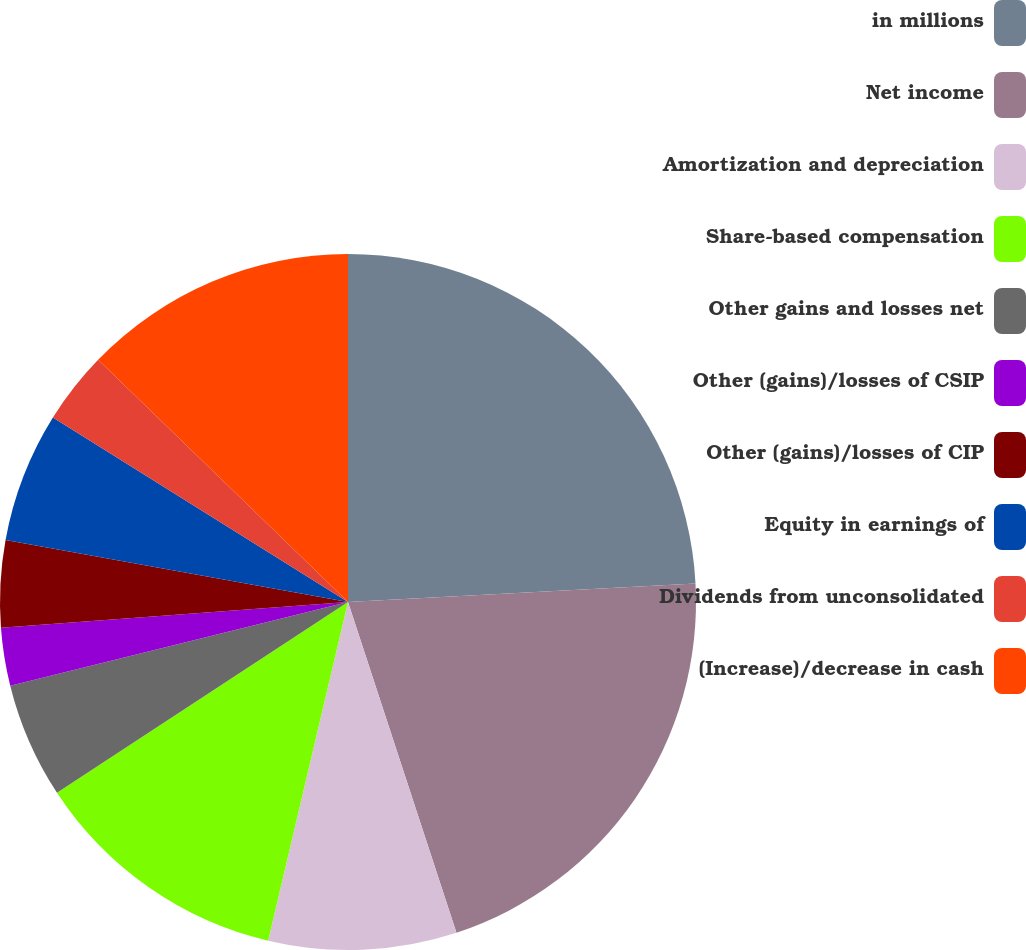Convert chart to OTSL. <chart><loc_0><loc_0><loc_500><loc_500><pie_chart><fcel>in millions<fcel>Net income<fcel>Amortization and depreciation<fcel>Share-based compensation<fcel>Other gains and losses net<fcel>Other (gains)/losses of CSIP<fcel>Other (gains)/losses of CIP<fcel>Equity in earnings of<fcel>Dividends from unconsolidated<fcel>(Increase)/decrease in cash<nl><fcel>24.16%<fcel>20.8%<fcel>8.73%<fcel>12.08%<fcel>5.37%<fcel>2.69%<fcel>4.03%<fcel>6.04%<fcel>3.36%<fcel>12.75%<nl></chart> 